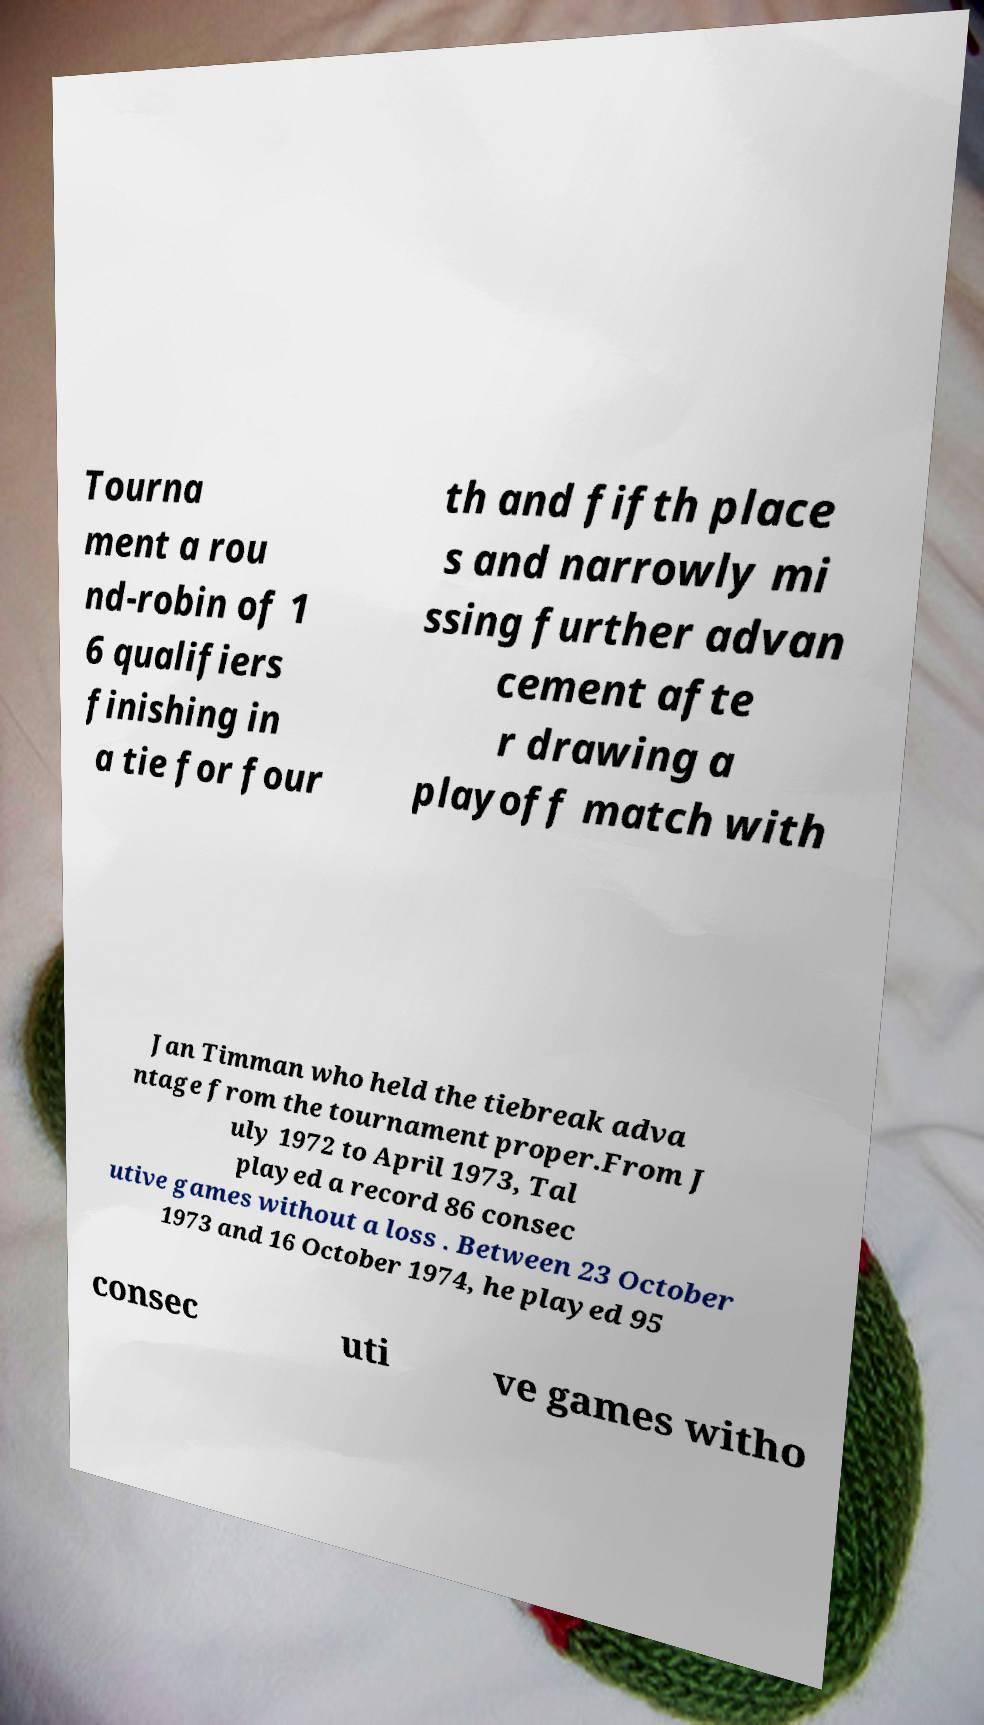I need the written content from this picture converted into text. Can you do that? Tourna ment a rou nd-robin of 1 6 qualifiers finishing in a tie for four th and fifth place s and narrowly mi ssing further advan cement afte r drawing a playoff match with Jan Timman who held the tiebreak adva ntage from the tournament proper.From J uly 1972 to April 1973, Tal played a record 86 consec utive games without a loss . Between 23 October 1973 and 16 October 1974, he played 95 consec uti ve games witho 